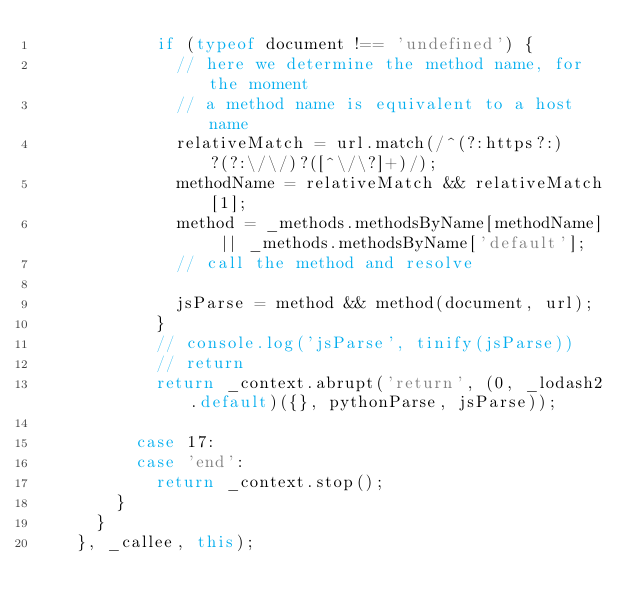<code> <loc_0><loc_0><loc_500><loc_500><_JavaScript_>            if (typeof document !== 'undefined') {
              // here we determine the method name, for the moment
              // a method name is equivalent to a host name
              relativeMatch = url.match(/^(?:https?:)?(?:\/\/)?([^\/\?]+)/);
              methodName = relativeMatch && relativeMatch[1];
              method = _methods.methodsByName[methodName] || _methods.methodsByName['default'];
              // call the method and resolve

              jsParse = method && method(document, url);
            }
            // console.log('jsParse', tinify(jsParse))
            // return
            return _context.abrupt('return', (0, _lodash2.default)({}, pythonParse, jsParse));

          case 17:
          case 'end':
            return _context.stop();
        }
      }
    }, _callee, this);</code> 